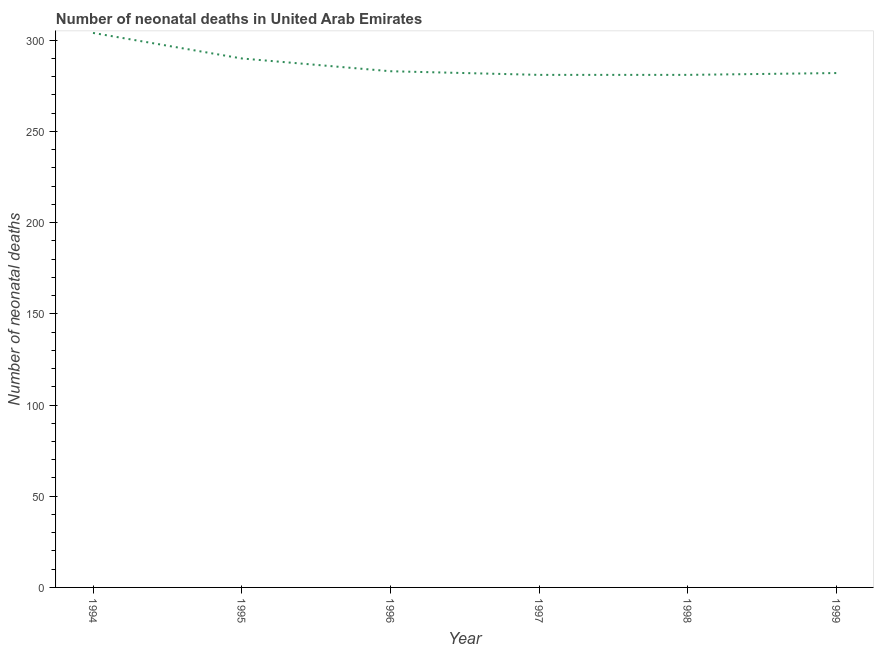What is the number of neonatal deaths in 1997?
Make the answer very short. 281. Across all years, what is the maximum number of neonatal deaths?
Ensure brevity in your answer.  304. Across all years, what is the minimum number of neonatal deaths?
Provide a succinct answer. 281. In which year was the number of neonatal deaths minimum?
Make the answer very short. 1997. What is the sum of the number of neonatal deaths?
Offer a terse response. 1721. What is the difference between the number of neonatal deaths in 1996 and 1999?
Give a very brief answer. 1. What is the average number of neonatal deaths per year?
Give a very brief answer. 286.83. What is the median number of neonatal deaths?
Provide a short and direct response. 282.5. In how many years, is the number of neonatal deaths greater than 280 ?
Make the answer very short. 6. Do a majority of the years between 1996 and 1997 (inclusive) have number of neonatal deaths greater than 100 ?
Offer a very short reply. Yes. What is the ratio of the number of neonatal deaths in 1998 to that in 1999?
Offer a terse response. 1. Is the difference between the number of neonatal deaths in 1994 and 1998 greater than the difference between any two years?
Make the answer very short. Yes. Is the sum of the number of neonatal deaths in 1996 and 1997 greater than the maximum number of neonatal deaths across all years?
Your answer should be compact. Yes. What is the difference between the highest and the lowest number of neonatal deaths?
Give a very brief answer. 23. In how many years, is the number of neonatal deaths greater than the average number of neonatal deaths taken over all years?
Make the answer very short. 2. Does the number of neonatal deaths monotonically increase over the years?
Your answer should be very brief. No. How many years are there in the graph?
Ensure brevity in your answer.  6. Are the values on the major ticks of Y-axis written in scientific E-notation?
Make the answer very short. No. Does the graph contain any zero values?
Ensure brevity in your answer.  No. What is the title of the graph?
Offer a very short reply. Number of neonatal deaths in United Arab Emirates. What is the label or title of the X-axis?
Make the answer very short. Year. What is the label or title of the Y-axis?
Keep it short and to the point. Number of neonatal deaths. What is the Number of neonatal deaths of 1994?
Make the answer very short. 304. What is the Number of neonatal deaths of 1995?
Provide a succinct answer. 290. What is the Number of neonatal deaths in 1996?
Provide a succinct answer. 283. What is the Number of neonatal deaths of 1997?
Your answer should be very brief. 281. What is the Number of neonatal deaths of 1998?
Your answer should be very brief. 281. What is the Number of neonatal deaths of 1999?
Your answer should be compact. 282. What is the difference between the Number of neonatal deaths in 1994 and 1996?
Your answer should be very brief. 21. What is the difference between the Number of neonatal deaths in 1994 and 1998?
Your answer should be very brief. 23. What is the difference between the Number of neonatal deaths in 1995 and 1999?
Ensure brevity in your answer.  8. What is the difference between the Number of neonatal deaths in 1996 and 1998?
Ensure brevity in your answer.  2. What is the difference between the Number of neonatal deaths in 1996 and 1999?
Offer a very short reply. 1. What is the difference between the Number of neonatal deaths in 1998 and 1999?
Your answer should be compact. -1. What is the ratio of the Number of neonatal deaths in 1994 to that in 1995?
Give a very brief answer. 1.05. What is the ratio of the Number of neonatal deaths in 1994 to that in 1996?
Give a very brief answer. 1.07. What is the ratio of the Number of neonatal deaths in 1994 to that in 1997?
Your answer should be compact. 1.08. What is the ratio of the Number of neonatal deaths in 1994 to that in 1998?
Keep it short and to the point. 1.08. What is the ratio of the Number of neonatal deaths in 1994 to that in 1999?
Provide a short and direct response. 1.08. What is the ratio of the Number of neonatal deaths in 1995 to that in 1996?
Your response must be concise. 1.02. What is the ratio of the Number of neonatal deaths in 1995 to that in 1997?
Ensure brevity in your answer.  1.03. What is the ratio of the Number of neonatal deaths in 1995 to that in 1998?
Your answer should be compact. 1.03. What is the ratio of the Number of neonatal deaths in 1995 to that in 1999?
Provide a succinct answer. 1.03. What is the ratio of the Number of neonatal deaths in 1997 to that in 1999?
Give a very brief answer. 1. 